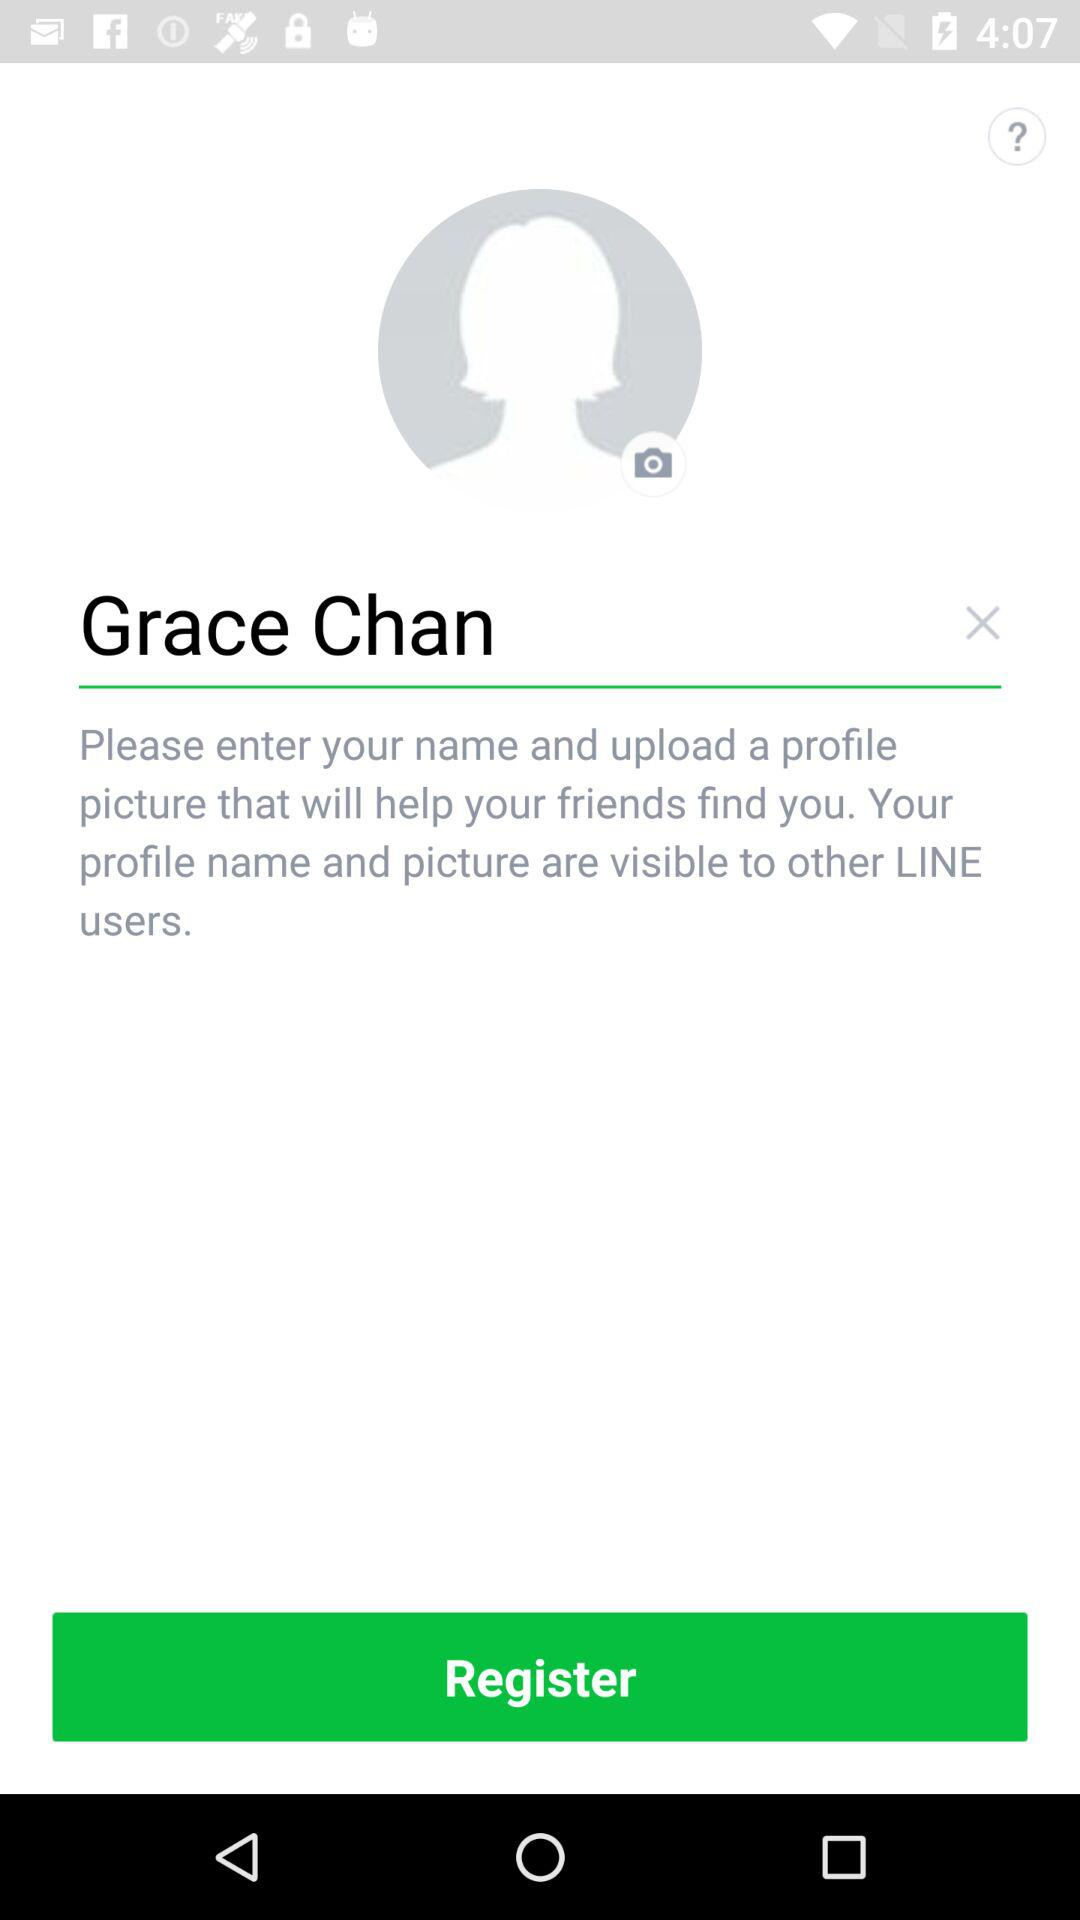What is visible to other "LINE" users? To other "LINE" users, the profile name and picture are visible. 